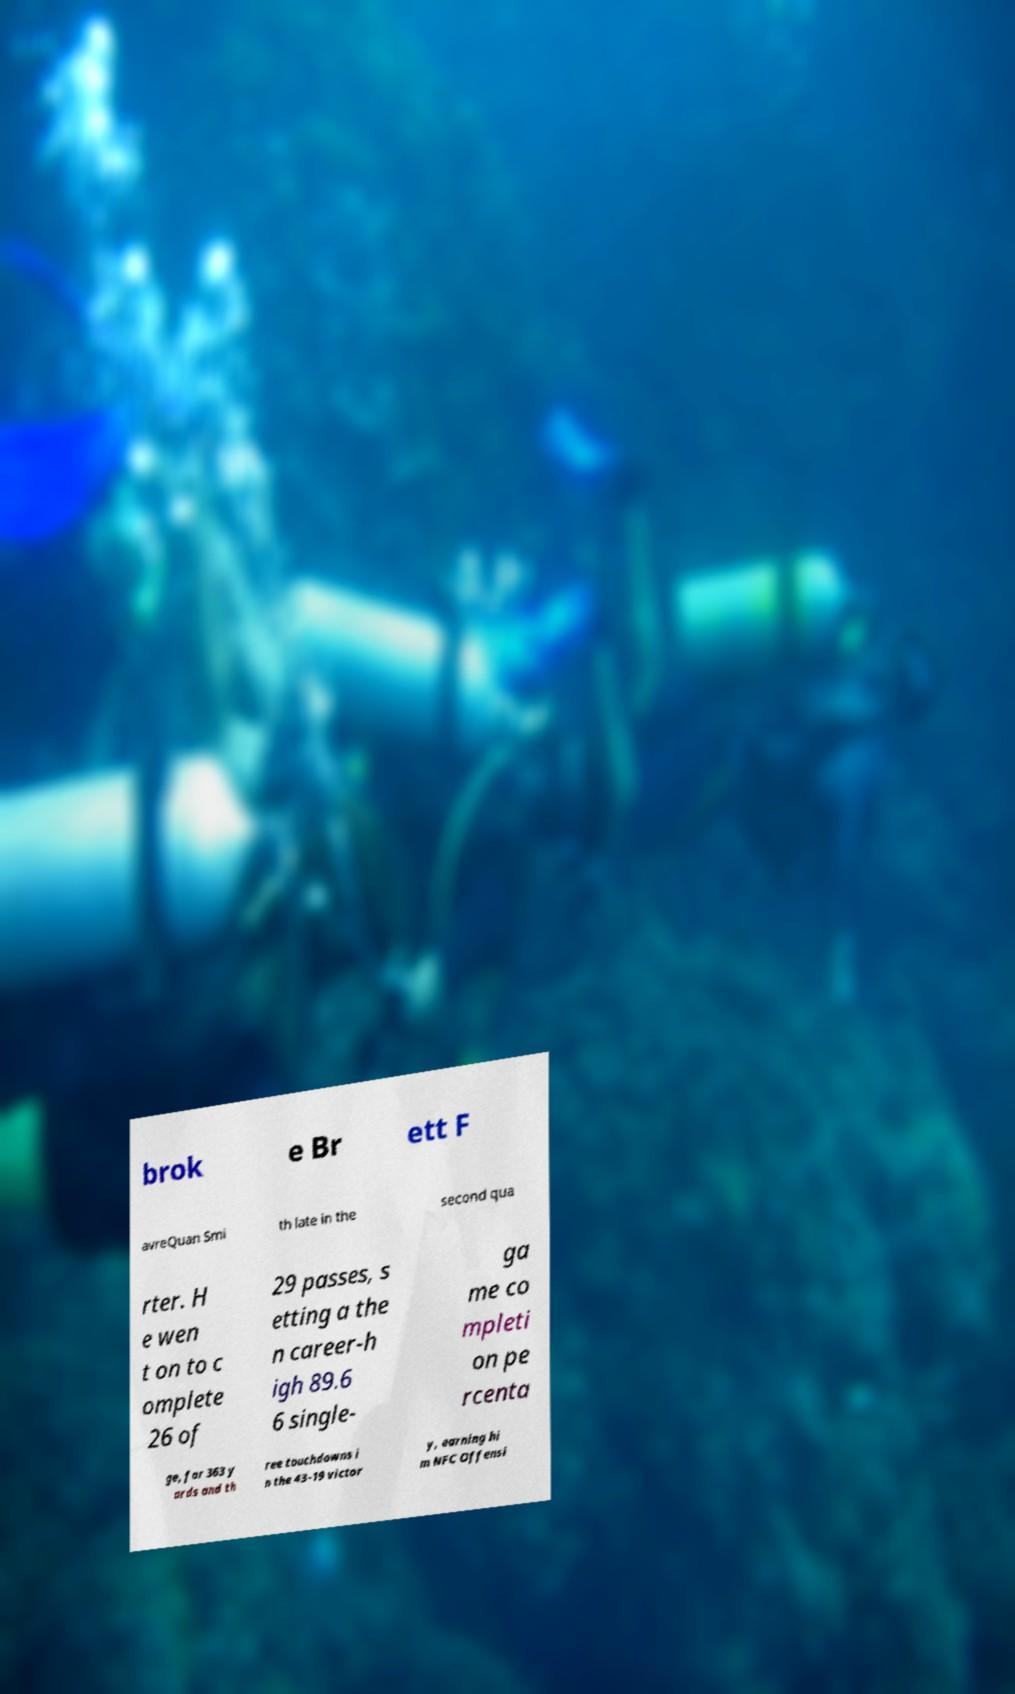Please read and relay the text visible in this image. What does it say? brok e Br ett F avreQuan Smi th late in the second qua rter. H e wen t on to c omplete 26 of 29 passes, s etting a the n career-h igh 89.6 6 single- ga me co mpleti on pe rcenta ge, for 363 y ards and th ree touchdowns i n the 43–19 victor y, earning hi m NFC Offensi 